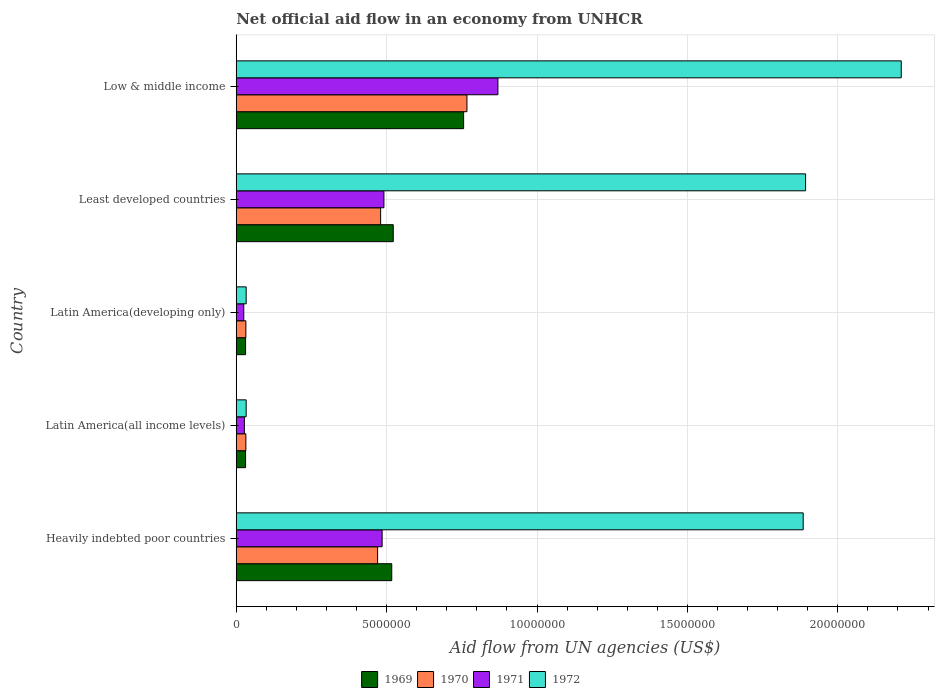How many different coloured bars are there?
Offer a terse response. 4. How many groups of bars are there?
Give a very brief answer. 5. Are the number of bars on each tick of the Y-axis equal?
Provide a short and direct response. Yes. What is the net official aid flow in 1970 in Least developed countries?
Your answer should be very brief. 4.80e+06. Across all countries, what is the maximum net official aid flow in 1972?
Provide a short and direct response. 2.21e+07. Across all countries, what is the minimum net official aid flow in 1969?
Give a very brief answer. 3.10e+05. In which country was the net official aid flow in 1969 minimum?
Your response must be concise. Latin America(all income levels). What is the total net official aid flow in 1970 in the graph?
Your answer should be compact. 1.78e+07. What is the difference between the net official aid flow in 1971 in Heavily indebted poor countries and that in Latin America(developing only)?
Provide a short and direct response. 4.60e+06. What is the difference between the net official aid flow in 1969 in Least developed countries and the net official aid flow in 1970 in Low & middle income?
Ensure brevity in your answer.  -2.45e+06. What is the average net official aid flow in 1971 per country?
Provide a succinct answer. 3.80e+06. What is the difference between the net official aid flow in 1970 and net official aid flow in 1972 in Heavily indebted poor countries?
Provide a succinct answer. -1.42e+07. In how many countries, is the net official aid flow in 1971 greater than 15000000 US$?
Give a very brief answer. 0. What is the ratio of the net official aid flow in 1970 in Heavily indebted poor countries to that in Latin America(developing only)?
Offer a terse response. 14.69. What is the difference between the highest and the second highest net official aid flow in 1970?
Make the answer very short. 2.87e+06. What is the difference between the highest and the lowest net official aid flow in 1972?
Ensure brevity in your answer.  2.18e+07. Is the sum of the net official aid flow in 1972 in Heavily indebted poor countries and Latin America(all income levels) greater than the maximum net official aid flow in 1969 across all countries?
Your answer should be very brief. Yes. What does the 4th bar from the top in Least developed countries represents?
Your answer should be compact. 1969. What does the 1st bar from the bottom in Latin America(all income levels) represents?
Provide a short and direct response. 1969. Are all the bars in the graph horizontal?
Ensure brevity in your answer.  Yes. Are the values on the major ticks of X-axis written in scientific E-notation?
Provide a short and direct response. No. Does the graph contain any zero values?
Your answer should be very brief. No. How are the legend labels stacked?
Your answer should be compact. Horizontal. What is the title of the graph?
Offer a terse response. Net official aid flow in an economy from UNHCR. What is the label or title of the X-axis?
Offer a terse response. Aid flow from UN agencies (US$). What is the Aid flow from UN agencies (US$) in 1969 in Heavily indebted poor countries?
Provide a short and direct response. 5.17e+06. What is the Aid flow from UN agencies (US$) in 1970 in Heavily indebted poor countries?
Keep it short and to the point. 4.70e+06. What is the Aid flow from UN agencies (US$) of 1971 in Heavily indebted poor countries?
Give a very brief answer. 4.85e+06. What is the Aid flow from UN agencies (US$) in 1972 in Heavily indebted poor countries?
Ensure brevity in your answer.  1.88e+07. What is the Aid flow from UN agencies (US$) in 1972 in Latin America(all income levels)?
Your answer should be very brief. 3.30e+05. What is the Aid flow from UN agencies (US$) of 1971 in Latin America(developing only)?
Make the answer very short. 2.50e+05. What is the Aid flow from UN agencies (US$) of 1969 in Least developed countries?
Offer a very short reply. 5.22e+06. What is the Aid flow from UN agencies (US$) in 1970 in Least developed countries?
Give a very brief answer. 4.80e+06. What is the Aid flow from UN agencies (US$) of 1971 in Least developed countries?
Provide a short and direct response. 4.91e+06. What is the Aid flow from UN agencies (US$) in 1972 in Least developed countries?
Your answer should be very brief. 1.89e+07. What is the Aid flow from UN agencies (US$) in 1969 in Low & middle income?
Provide a short and direct response. 7.56e+06. What is the Aid flow from UN agencies (US$) in 1970 in Low & middle income?
Keep it short and to the point. 7.67e+06. What is the Aid flow from UN agencies (US$) in 1971 in Low & middle income?
Offer a terse response. 8.70e+06. What is the Aid flow from UN agencies (US$) in 1972 in Low & middle income?
Offer a very short reply. 2.21e+07. Across all countries, what is the maximum Aid flow from UN agencies (US$) of 1969?
Ensure brevity in your answer.  7.56e+06. Across all countries, what is the maximum Aid flow from UN agencies (US$) in 1970?
Keep it short and to the point. 7.67e+06. Across all countries, what is the maximum Aid flow from UN agencies (US$) of 1971?
Offer a terse response. 8.70e+06. Across all countries, what is the maximum Aid flow from UN agencies (US$) in 1972?
Offer a terse response. 2.21e+07. Across all countries, what is the minimum Aid flow from UN agencies (US$) in 1969?
Ensure brevity in your answer.  3.10e+05. Across all countries, what is the minimum Aid flow from UN agencies (US$) in 1970?
Keep it short and to the point. 3.20e+05. Across all countries, what is the minimum Aid flow from UN agencies (US$) in 1971?
Offer a terse response. 2.50e+05. What is the total Aid flow from UN agencies (US$) of 1969 in the graph?
Your answer should be compact. 1.86e+07. What is the total Aid flow from UN agencies (US$) of 1970 in the graph?
Your answer should be compact. 1.78e+07. What is the total Aid flow from UN agencies (US$) in 1971 in the graph?
Provide a short and direct response. 1.90e+07. What is the total Aid flow from UN agencies (US$) of 1972 in the graph?
Provide a succinct answer. 6.06e+07. What is the difference between the Aid flow from UN agencies (US$) in 1969 in Heavily indebted poor countries and that in Latin America(all income levels)?
Provide a succinct answer. 4.86e+06. What is the difference between the Aid flow from UN agencies (US$) of 1970 in Heavily indebted poor countries and that in Latin America(all income levels)?
Offer a terse response. 4.38e+06. What is the difference between the Aid flow from UN agencies (US$) in 1971 in Heavily indebted poor countries and that in Latin America(all income levels)?
Ensure brevity in your answer.  4.58e+06. What is the difference between the Aid flow from UN agencies (US$) in 1972 in Heavily indebted poor countries and that in Latin America(all income levels)?
Make the answer very short. 1.85e+07. What is the difference between the Aid flow from UN agencies (US$) in 1969 in Heavily indebted poor countries and that in Latin America(developing only)?
Provide a short and direct response. 4.86e+06. What is the difference between the Aid flow from UN agencies (US$) in 1970 in Heavily indebted poor countries and that in Latin America(developing only)?
Keep it short and to the point. 4.38e+06. What is the difference between the Aid flow from UN agencies (US$) of 1971 in Heavily indebted poor countries and that in Latin America(developing only)?
Your response must be concise. 4.60e+06. What is the difference between the Aid flow from UN agencies (US$) in 1972 in Heavily indebted poor countries and that in Latin America(developing only)?
Make the answer very short. 1.85e+07. What is the difference between the Aid flow from UN agencies (US$) in 1969 in Heavily indebted poor countries and that in Least developed countries?
Provide a short and direct response. -5.00e+04. What is the difference between the Aid flow from UN agencies (US$) in 1970 in Heavily indebted poor countries and that in Least developed countries?
Provide a short and direct response. -1.00e+05. What is the difference between the Aid flow from UN agencies (US$) of 1971 in Heavily indebted poor countries and that in Least developed countries?
Provide a succinct answer. -6.00e+04. What is the difference between the Aid flow from UN agencies (US$) of 1972 in Heavily indebted poor countries and that in Least developed countries?
Give a very brief answer. -8.00e+04. What is the difference between the Aid flow from UN agencies (US$) of 1969 in Heavily indebted poor countries and that in Low & middle income?
Provide a short and direct response. -2.39e+06. What is the difference between the Aid flow from UN agencies (US$) in 1970 in Heavily indebted poor countries and that in Low & middle income?
Offer a very short reply. -2.97e+06. What is the difference between the Aid flow from UN agencies (US$) in 1971 in Heavily indebted poor countries and that in Low & middle income?
Offer a very short reply. -3.85e+06. What is the difference between the Aid flow from UN agencies (US$) in 1972 in Heavily indebted poor countries and that in Low & middle income?
Provide a short and direct response. -3.26e+06. What is the difference between the Aid flow from UN agencies (US$) of 1972 in Latin America(all income levels) and that in Latin America(developing only)?
Offer a terse response. 0. What is the difference between the Aid flow from UN agencies (US$) of 1969 in Latin America(all income levels) and that in Least developed countries?
Offer a very short reply. -4.91e+06. What is the difference between the Aid flow from UN agencies (US$) in 1970 in Latin America(all income levels) and that in Least developed countries?
Offer a terse response. -4.48e+06. What is the difference between the Aid flow from UN agencies (US$) in 1971 in Latin America(all income levels) and that in Least developed countries?
Your answer should be compact. -4.64e+06. What is the difference between the Aid flow from UN agencies (US$) in 1972 in Latin America(all income levels) and that in Least developed countries?
Your answer should be compact. -1.86e+07. What is the difference between the Aid flow from UN agencies (US$) in 1969 in Latin America(all income levels) and that in Low & middle income?
Your answer should be very brief. -7.25e+06. What is the difference between the Aid flow from UN agencies (US$) in 1970 in Latin America(all income levels) and that in Low & middle income?
Keep it short and to the point. -7.35e+06. What is the difference between the Aid flow from UN agencies (US$) of 1971 in Latin America(all income levels) and that in Low & middle income?
Provide a short and direct response. -8.43e+06. What is the difference between the Aid flow from UN agencies (US$) in 1972 in Latin America(all income levels) and that in Low & middle income?
Offer a very short reply. -2.18e+07. What is the difference between the Aid flow from UN agencies (US$) in 1969 in Latin America(developing only) and that in Least developed countries?
Provide a succinct answer. -4.91e+06. What is the difference between the Aid flow from UN agencies (US$) in 1970 in Latin America(developing only) and that in Least developed countries?
Your response must be concise. -4.48e+06. What is the difference between the Aid flow from UN agencies (US$) of 1971 in Latin America(developing only) and that in Least developed countries?
Keep it short and to the point. -4.66e+06. What is the difference between the Aid flow from UN agencies (US$) of 1972 in Latin America(developing only) and that in Least developed countries?
Your answer should be very brief. -1.86e+07. What is the difference between the Aid flow from UN agencies (US$) in 1969 in Latin America(developing only) and that in Low & middle income?
Offer a very short reply. -7.25e+06. What is the difference between the Aid flow from UN agencies (US$) in 1970 in Latin America(developing only) and that in Low & middle income?
Your answer should be compact. -7.35e+06. What is the difference between the Aid flow from UN agencies (US$) in 1971 in Latin America(developing only) and that in Low & middle income?
Your answer should be compact. -8.45e+06. What is the difference between the Aid flow from UN agencies (US$) in 1972 in Latin America(developing only) and that in Low & middle income?
Give a very brief answer. -2.18e+07. What is the difference between the Aid flow from UN agencies (US$) of 1969 in Least developed countries and that in Low & middle income?
Keep it short and to the point. -2.34e+06. What is the difference between the Aid flow from UN agencies (US$) of 1970 in Least developed countries and that in Low & middle income?
Your answer should be very brief. -2.87e+06. What is the difference between the Aid flow from UN agencies (US$) in 1971 in Least developed countries and that in Low & middle income?
Offer a terse response. -3.79e+06. What is the difference between the Aid flow from UN agencies (US$) of 1972 in Least developed countries and that in Low & middle income?
Provide a succinct answer. -3.18e+06. What is the difference between the Aid flow from UN agencies (US$) in 1969 in Heavily indebted poor countries and the Aid flow from UN agencies (US$) in 1970 in Latin America(all income levels)?
Give a very brief answer. 4.85e+06. What is the difference between the Aid flow from UN agencies (US$) in 1969 in Heavily indebted poor countries and the Aid flow from UN agencies (US$) in 1971 in Latin America(all income levels)?
Provide a short and direct response. 4.90e+06. What is the difference between the Aid flow from UN agencies (US$) in 1969 in Heavily indebted poor countries and the Aid flow from UN agencies (US$) in 1972 in Latin America(all income levels)?
Your response must be concise. 4.84e+06. What is the difference between the Aid flow from UN agencies (US$) in 1970 in Heavily indebted poor countries and the Aid flow from UN agencies (US$) in 1971 in Latin America(all income levels)?
Ensure brevity in your answer.  4.43e+06. What is the difference between the Aid flow from UN agencies (US$) of 1970 in Heavily indebted poor countries and the Aid flow from UN agencies (US$) of 1972 in Latin America(all income levels)?
Offer a very short reply. 4.37e+06. What is the difference between the Aid flow from UN agencies (US$) in 1971 in Heavily indebted poor countries and the Aid flow from UN agencies (US$) in 1972 in Latin America(all income levels)?
Offer a terse response. 4.52e+06. What is the difference between the Aid flow from UN agencies (US$) of 1969 in Heavily indebted poor countries and the Aid flow from UN agencies (US$) of 1970 in Latin America(developing only)?
Offer a very short reply. 4.85e+06. What is the difference between the Aid flow from UN agencies (US$) of 1969 in Heavily indebted poor countries and the Aid flow from UN agencies (US$) of 1971 in Latin America(developing only)?
Offer a terse response. 4.92e+06. What is the difference between the Aid flow from UN agencies (US$) of 1969 in Heavily indebted poor countries and the Aid flow from UN agencies (US$) of 1972 in Latin America(developing only)?
Your response must be concise. 4.84e+06. What is the difference between the Aid flow from UN agencies (US$) in 1970 in Heavily indebted poor countries and the Aid flow from UN agencies (US$) in 1971 in Latin America(developing only)?
Provide a succinct answer. 4.45e+06. What is the difference between the Aid flow from UN agencies (US$) in 1970 in Heavily indebted poor countries and the Aid flow from UN agencies (US$) in 1972 in Latin America(developing only)?
Your response must be concise. 4.37e+06. What is the difference between the Aid flow from UN agencies (US$) in 1971 in Heavily indebted poor countries and the Aid flow from UN agencies (US$) in 1972 in Latin America(developing only)?
Give a very brief answer. 4.52e+06. What is the difference between the Aid flow from UN agencies (US$) in 1969 in Heavily indebted poor countries and the Aid flow from UN agencies (US$) in 1972 in Least developed countries?
Offer a terse response. -1.38e+07. What is the difference between the Aid flow from UN agencies (US$) of 1970 in Heavily indebted poor countries and the Aid flow from UN agencies (US$) of 1971 in Least developed countries?
Your answer should be very brief. -2.10e+05. What is the difference between the Aid flow from UN agencies (US$) in 1970 in Heavily indebted poor countries and the Aid flow from UN agencies (US$) in 1972 in Least developed countries?
Your response must be concise. -1.42e+07. What is the difference between the Aid flow from UN agencies (US$) in 1971 in Heavily indebted poor countries and the Aid flow from UN agencies (US$) in 1972 in Least developed countries?
Your answer should be compact. -1.41e+07. What is the difference between the Aid flow from UN agencies (US$) of 1969 in Heavily indebted poor countries and the Aid flow from UN agencies (US$) of 1970 in Low & middle income?
Your answer should be very brief. -2.50e+06. What is the difference between the Aid flow from UN agencies (US$) of 1969 in Heavily indebted poor countries and the Aid flow from UN agencies (US$) of 1971 in Low & middle income?
Offer a very short reply. -3.53e+06. What is the difference between the Aid flow from UN agencies (US$) of 1969 in Heavily indebted poor countries and the Aid flow from UN agencies (US$) of 1972 in Low & middle income?
Offer a very short reply. -1.69e+07. What is the difference between the Aid flow from UN agencies (US$) in 1970 in Heavily indebted poor countries and the Aid flow from UN agencies (US$) in 1972 in Low & middle income?
Offer a terse response. -1.74e+07. What is the difference between the Aid flow from UN agencies (US$) in 1971 in Heavily indebted poor countries and the Aid flow from UN agencies (US$) in 1972 in Low & middle income?
Your answer should be compact. -1.73e+07. What is the difference between the Aid flow from UN agencies (US$) of 1969 in Latin America(all income levels) and the Aid flow from UN agencies (US$) of 1970 in Latin America(developing only)?
Provide a succinct answer. -10000. What is the difference between the Aid flow from UN agencies (US$) of 1969 in Latin America(all income levels) and the Aid flow from UN agencies (US$) of 1971 in Latin America(developing only)?
Provide a succinct answer. 6.00e+04. What is the difference between the Aid flow from UN agencies (US$) in 1969 in Latin America(all income levels) and the Aid flow from UN agencies (US$) in 1970 in Least developed countries?
Your answer should be very brief. -4.49e+06. What is the difference between the Aid flow from UN agencies (US$) of 1969 in Latin America(all income levels) and the Aid flow from UN agencies (US$) of 1971 in Least developed countries?
Your response must be concise. -4.60e+06. What is the difference between the Aid flow from UN agencies (US$) in 1969 in Latin America(all income levels) and the Aid flow from UN agencies (US$) in 1972 in Least developed countries?
Provide a short and direct response. -1.86e+07. What is the difference between the Aid flow from UN agencies (US$) of 1970 in Latin America(all income levels) and the Aid flow from UN agencies (US$) of 1971 in Least developed countries?
Make the answer very short. -4.59e+06. What is the difference between the Aid flow from UN agencies (US$) of 1970 in Latin America(all income levels) and the Aid flow from UN agencies (US$) of 1972 in Least developed countries?
Your response must be concise. -1.86e+07. What is the difference between the Aid flow from UN agencies (US$) of 1971 in Latin America(all income levels) and the Aid flow from UN agencies (US$) of 1972 in Least developed countries?
Provide a succinct answer. -1.87e+07. What is the difference between the Aid flow from UN agencies (US$) of 1969 in Latin America(all income levels) and the Aid flow from UN agencies (US$) of 1970 in Low & middle income?
Your answer should be very brief. -7.36e+06. What is the difference between the Aid flow from UN agencies (US$) in 1969 in Latin America(all income levels) and the Aid flow from UN agencies (US$) in 1971 in Low & middle income?
Offer a very short reply. -8.39e+06. What is the difference between the Aid flow from UN agencies (US$) in 1969 in Latin America(all income levels) and the Aid flow from UN agencies (US$) in 1972 in Low & middle income?
Make the answer very short. -2.18e+07. What is the difference between the Aid flow from UN agencies (US$) of 1970 in Latin America(all income levels) and the Aid flow from UN agencies (US$) of 1971 in Low & middle income?
Offer a terse response. -8.38e+06. What is the difference between the Aid flow from UN agencies (US$) of 1970 in Latin America(all income levels) and the Aid flow from UN agencies (US$) of 1972 in Low & middle income?
Provide a succinct answer. -2.18e+07. What is the difference between the Aid flow from UN agencies (US$) of 1971 in Latin America(all income levels) and the Aid flow from UN agencies (US$) of 1972 in Low & middle income?
Provide a succinct answer. -2.18e+07. What is the difference between the Aid flow from UN agencies (US$) of 1969 in Latin America(developing only) and the Aid flow from UN agencies (US$) of 1970 in Least developed countries?
Offer a very short reply. -4.49e+06. What is the difference between the Aid flow from UN agencies (US$) in 1969 in Latin America(developing only) and the Aid flow from UN agencies (US$) in 1971 in Least developed countries?
Ensure brevity in your answer.  -4.60e+06. What is the difference between the Aid flow from UN agencies (US$) of 1969 in Latin America(developing only) and the Aid flow from UN agencies (US$) of 1972 in Least developed countries?
Your answer should be very brief. -1.86e+07. What is the difference between the Aid flow from UN agencies (US$) in 1970 in Latin America(developing only) and the Aid flow from UN agencies (US$) in 1971 in Least developed countries?
Provide a short and direct response. -4.59e+06. What is the difference between the Aid flow from UN agencies (US$) in 1970 in Latin America(developing only) and the Aid flow from UN agencies (US$) in 1972 in Least developed countries?
Ensure brevity in your answer.  -1.86e+07. What is the difference between the Aid flow from UN agencies (US$) of 1971 in Latin America(developing only) and the Aid flow from UN agencies (US$) of 1972 in Least developed countries?
Ensure brevity in your answer.  -1.87e+07. What is the difference between the Aid flow from UN agencies (US$) of 1969 in Latin America(developing only) and the Aid flow from UN agencies (US$) of 1970 in Low & middle income?
Offer a very short reply. -7.36e+06. What is the difference between the Aid flow from UN agencies (US$) of 1969 in Latin America(developing only) and the Aid flow from UN agencies (US$) of 1971 in Low & middle income?
Make the answer very short. -8.39e+06. What is the difference between the Aid flow from UN agencies (US$) in 1969 in Latin America(developing only) and the Aid flow from UN agencies (US$) in 1972 in Low & middle income?
Your answer should be very brief. -2.18e+07. What is the difference between the Aid flow from UN agencies (US$) in 1970 in Latin America(developing only) and the Aid flow from UN agencies (US$) in 1971 in Low & middle income?
Provide a succinct answer. -8.38e+06. What is the difference between the Aid flow from UN agencies (US$) of 1970 in Latin America(developing only) and the Aid flow from UN agencies (US$) of 1972 in Low & middle income?
Provide a short and direct response. -2.18e+07. What is the difference between the Aid flow from UN agencies (US$) of 1971 in Latin America(developing only) and the Aid flow from UN agencies (US$) of 1972 in Low & middle income?
Keep it short and to the point. -2.19e+07. What is the difference between the Aid flow from UN agencies (US$) in 1969 in Least developed countries and the Aid flow from UN agencies (US$) in 1970 in Low & middle income?
Offer a very short reply. -2.45e+06. What is the difference between the Aid flow from UN agencies (US$) of 1969 in Least developed countries and the Aid flow from UN agencies (US$) of 1971 in Low & middle income?
Ensure brevity in your answer.  -3.48e+06. What is the difference between the Aid flow from UN agencies (US$) of 1969 in Least developed countries and the Aid flow from UN agencies (US$) of 1972 in Low & middle income?
Your answer should be compact. -1.69e+07. What is the difference between the Aid flow from UN agencies (US$) of 1970 in Least developed countries and the Aid flow from UN agencies (US$) of 1971 in Low & middle income?
Offer a terse response. -3.90e+06. What is the difference between the Aid flow from UN agencies (US$) of 1970 in Least developed countries and the Aid flow from UN agencies (US$) of 1972 in Low & middle income?
Provide a short and direct response. -1.73e+07. What is the difference between the Aid flow from UN agencies (US$) of 1971 in Least developed countries and the Aid flow from UN agencies (US$) of 1972 in Low & middle income?
Provide a short and direct response. -1.72e+07. What is the average Aid flow from UN agencies (US$) in 1969 per country?
Give a very brief answer. 3.71e+06. What is the average Aid flow from UN agencies (US$) of 1970 per country?
Your answer should be compact. 3.56e+06. What is the average Aid flow from UN agencies (US$) of 1971 per country?
Offer a terse response. 3.80e+06. What is the average Aid flow from UN agencies (US$) in 1972 per country?
Your answer should be compact. 1.21e+07. What is the difference between the Aid flow from UN agencies (US$) in 1969 and Aid flow from UN agencies (US$) in 1970 in Heavily indebted poor countries?
Your answer should be compact. 4.70e+05. What is the difference between the Aid flow from UN agencies (US$) of 1969 and Aid flow from UN agencies (US$) of 1972 in Heavily indebted poor countries?
Offer a very short reply. -1.37e+07. What is the difference between the Aid flow from UN agencies (US$) of 1970 and Aid flow from UN agencies (US$) of 1971 in Heavily indebted poor countries?
Ensure brevity in your answer.  -1.50e+05. What is the difference between the Aid flow from UN agencies (US$) of 1970 and Aid flow from UN agencies (US$) of 1972 in Heavily indebted poor countries?
Give a very brief answer. -1.42e+07. What is the difference between the Aid flow from UN agencies (US$) of 1971 and Aid flow from UN agencies (US$) of 1972 in Heavily indebted poor countries?
Your answer should be very brief. -1.40e+07. What is the difference between the Aid flow from UN agencies (US$) in 1969 and Aid flow from UN agencies (US$) in 1970 in Latin America(all income levels)?
Keep it short and to the point. -10000. What is the difference between the Aid flow from UN agencies (US$) of 1970 and Aid flow from UN agencies (US$) of 1971 in Latin America(all income levels)?
Give a very brief answer. 5.00e+04. What is the difference between the Aid flow from UN agencies (US$) of 1970 and Aid flow from UN agencies (US$) of 1972 in Latin America(all income levels)?
Offer a terse response. -10000. What is the difference between the Aid flow from UN agencies (US$) in 1971 and Aid flow from UN agencies (US$) in 1972 in Latin America(all income levels)?
Your answer should be very brief. -6.00e+04. What is the difference between the Aid flow from UN agencies (US$) in 1969 and Aid flow from UN agencies (US$) in 1972 in Latin America(developing only)?
Offer a terse response. -2.00e+04. What is the difference between the Aid flow from UN agencies (US$) of 1970 and Aid flow from UN agencies (US$) of 1972 in Latin America(developing only)?
Your response must be concise. -10000. What is the difference between the Aid flow from UN agencies (US$) of 1971 and Aid flow from UN agencies (US$) of 1972 in Latin America(developing only)?
Make the answer very short. -8.00e+04. What is the difference between the Aid flow from UN agencies (US$) in 1969 and Aid flow from UN agencies (US$) in 1972 in Least developed countries?
Offer a terse response. -1.37e+07. What is the difference between the Aid flow from UN agencies (US$) in 1970 and Aid flow from UN agencies (US$) in 1971 in Least developed countries?
Your response must be concise. -1.10e+05. What is the difference between the Aid flow from UN agencies (US$) of 1970 and Aid flow from UN agencies (US$) of 1972 in Least developed countries?
Keep it short and to the point. -1.41e+07. What is the difference between the Aid flow from UN agencies (US$) of 1971 and Aid flow from UN agencies (US$) of 1972 in Least developed countries?
Ensure brevity in your answer.  -1.40e+07. What is the difference between the Aid flow from UN agencies (US$) in 1969 and Aid flow from UN agencies (US$) in 1970 in Low & middle income?
Your response must be concise. -1.10e+05. What is the difference between the Aid flow from UN agencies (US$) of 1969 and Aid flow from UN agencies (US$) of 1971 in Low & middle income?
Offer a very short reply. -1.14e+06. What is the difference between the Aid flow from UN agencies (US$) in 1969 and Aid flow from UN agencies (US$) in 1972 in Low & middle income?
Provide a short and direct response. -1.46e+07. What is the difference between the Aid flow from UN agencies (US$) in 1970 and Aid flow from UN agencies (US$) in 1971 in Low & middle income?
Offer a terse response. -1.03e+06. What is the difference between the Aid flow from UN agencies (US$) of 1970 and Aid flow from UN agencies (US$) of 1972 in Low & middle income?
Offer a terse response. -1.44e+07. What is the difference between the Aid flow from UN agencies (US$) of 1971 and Aid flow from UN agencies (US$) of 1972 in Low & middle income?
Your answer should be compact. -1.34e+07. What is the ratio of the Aid flow from UN agencies (US$) of 1969 in Heavily indebted poor countries to that in Latin America(all income levels)?
Give a very brief answer. 16.68. What is the ratio of the Aid flow from UN agencies (US$) of 1970 in Heavily indebted poor countries to that in Latin America(all income levels)?
Ensure brevity in your answer.  14.69. What is the ratio of the Aid flow from UN agencies (US$) of 1971 in Heavily indebted poor countries to that in Latin America(all income levels)?
Provide a succinct answer. 17.96. What is the ratio of the Aid flow from UN agencies (US$) in 1972 in Heavily indebted poor countries to that in Latin America(all income levels)?
Offer a terse response. 57.12. What is the ratio of the Aid flow from UN agencies (US$) of 1969 in Heavily indebted poor countries to that in Latin America(developing only)?
Provide a succinct answer. 16.68. What is the ratio of the Aid flow from UN agencies (US$) of 1970 in Heavily indebted poor countries to that in Latin America(developing only)?
Your response must be concise. 14.69. What is the ratio of the Aid flow from UN agencies (US$) of 1972 in Heavily indebted poor countries to that in Latin America(developing only)?
Keep it short and to the point. 57.12. What is the ratio of the Aid flow from UN agencies (US$) of 1970 in Heavily indebted poor countries to that in Least developed countries?
Your answer should be compact. 0.98. What is the ratio of the Aid flow from UN agencies (US$) of 1971 in Heavily indebted poor countries to that in Least developed countries?
Your response must be concise. 0.99. What is the ratio of the Aid flow from UN agencies (US$) of 1972 in Heavily indebted poor countries to that in Least developed countries?
Give a very brief answer. 1. What is the ratio of the Aid flow from UN agencies (US$) of 1969 in Heavily indebted poor countries to that in Low & middle income?
Make the answer very short. 0.68. What is the ratio of the Aid flow from UN agencies (US$) of 1970 in Heavily indebted poor countries to that in Low & middle income?
Offer a terse response. 0.61. What is the ratio of the Aid flow from UN agencies (US$) in 1971 in Heavily indebted poor countries to that in Low & middle income?
Ensure brevity in your answer.  0.56. What is the ratio of the Aid flow from UN agencies (US$) of 1972 in Heavily indebted poor countries to that in Low & middle income?
Provide a succinct answer. 0.85. What is the ratio of the Aid flow from UN agencies (US$) of 1969 in Latin America(all income levels) to that in Latin America(developing only)?
Offer a very short reply. 1. What is the ratio of the Aid flow from UN agencies (US$) of 1971 in Latin America(all income levels) to that in Latin America(developing only)?
Ensure brevity in your answer.  1.08. What is the ratio of the Aid flow from UN agencies (US$) in 1969 in Latin America(all income levels) to that in Least developed countries?
Your response must be concise. 0.06. What is the ratio of the Aid flow from UN agencies (US$) of 1970 in Latin America(all income levels) to that in Least developed countries?
Ensure brevity in your answer.  0.07. What is the ratio of the Aid flow from UN agencies (US$) in 1971 in Latin America(all income levels) to that in Least developed countries?
Your answer should be very brief. 0.06. What is the ratio of the Aid flow from UN agencies (US$) of 1972 in Latin America(all income levels) to that in Least developed countries?
Your answer should be compact. 0.02. What is the ratio of the Aid flow from UN agencies (US$) of 1969 in Latin America(all income levels) to that in Low & middle income?
Give a very brief answer. 0.04. What is the ratio of the Aid flow from UN agencies (US$) in 1970 in Latin America(all income levels) to that in Low & middle income?
Provide a succinct answer. 0.04. What is the ratio of the Aid flow from UN agencies (US$) in 1971 in Latin America(all income levels) to that in Low & middle income?
Keep it short and to the point. 0.03. What is the ratio of the Aid flow from UN agencies (US$) in 1972 in Latin America(all income levels) to that in Low & middle income?
Ensure brevity in your answer.  0.01. What is the ratio of the Aid flow from UN agencies (US$) of 1969 in Latin America(developing only) to that in Least developed countries?
Provide a short and direct response. 0.06. What is the ratio of the Aid flow from UN agencies (US$) of 1970 in Latin America(developing only) to that in Least developed countries?
Keep it short and to the point. 0.07. What is the ratio of the Aid flow from UN agencies (US$) in 1971 in Latin America(developing only) to that in Least developed countries?
Provide a succinct answer. 0.05. What is the ratio of the Aid flow from UN agencies (US$) of 1972 in Latin America(developing only) to that in Least developed countries?
Your answer should be very brief. 0.02. What is the ratio of the Aid flow from UN agencies (US$) of 1969 in Latin America(developing only) to that in Low & middle income?
Provide a succinct answer. 0.04. What is the ratio of the Aid flow from UN agencies (US$) in 1970 in Latin America(developing only) to that in Low & middle income?
Your response must be concise. 0.04. What is the ratio of the Aid flow from UN agencies (US$) of 1971 in Latin America(developing only) to that in Low & middle income?
Offer a terse response. 0.03. What is the ratio of the Aid flow from UN agencies (US$) of 1972 in Latin America(developing only) to that in Low & middle income?
Keep it short and to the point. 0.01. What is the ratio of the Aid flow from UN agencies (US$) in 1969 in Least developed countries to that in Low & middle income?
Ensure brevity in your answer.  0.69. What is the ratio of the Aid flow from UN agencies (US$) of 1970 in Least developed countries to that in Low & middle income?
Provide a short and direct response. 0.63. What is the ratio of the Aid flow from UN agencies (US$) in 1971 in Least developed countries to that in Low & middle income?
Ensure brevity in your answer.  0.56. What is the ratio of the Aid flow from UN agencies (US$) of 1972 in Least developed countries to that in Low & middle income?
Your answer should be compact. 0.86. What is the difference between the highest and the second highest Aid flow from UN agencies (US$) in 1969?
Your answer should be very brief. 2.34e+06. What is the difference between the highest and the second highest Aid flow from UN agencies (US$) in 1970?
Give a very brief answer. 2.87e+06. What is the difference between the highest and the second highest Aid flow from UN agencies (US$) in 1971?
Keep it short and to the point. 3.79e+06. What is the difference between the highest and the second highest Aid flow from UN agencies (US$) in 1972?
Give a very brief answer. 3.18e+06. What is the difference between the highest and the lowest Aid flow from UN agencies (US$) of 1969?
Offer a very short reply. 7.25e+06. What is the difference between the highest and the lowest Aid flow from UN agencies (US$) in 1970?
Keep it short and to the point. 7.35e+06. What is the difference between the highest and the lowest Aid flow from UN agencies (US$) of 1971?
Offer a very short reply. 8.45e+06. What is the difference between the highest and the lowest Aid flow from UN agencies (US$) in 1972?
Offer a very short reply. 2.18e+07. 